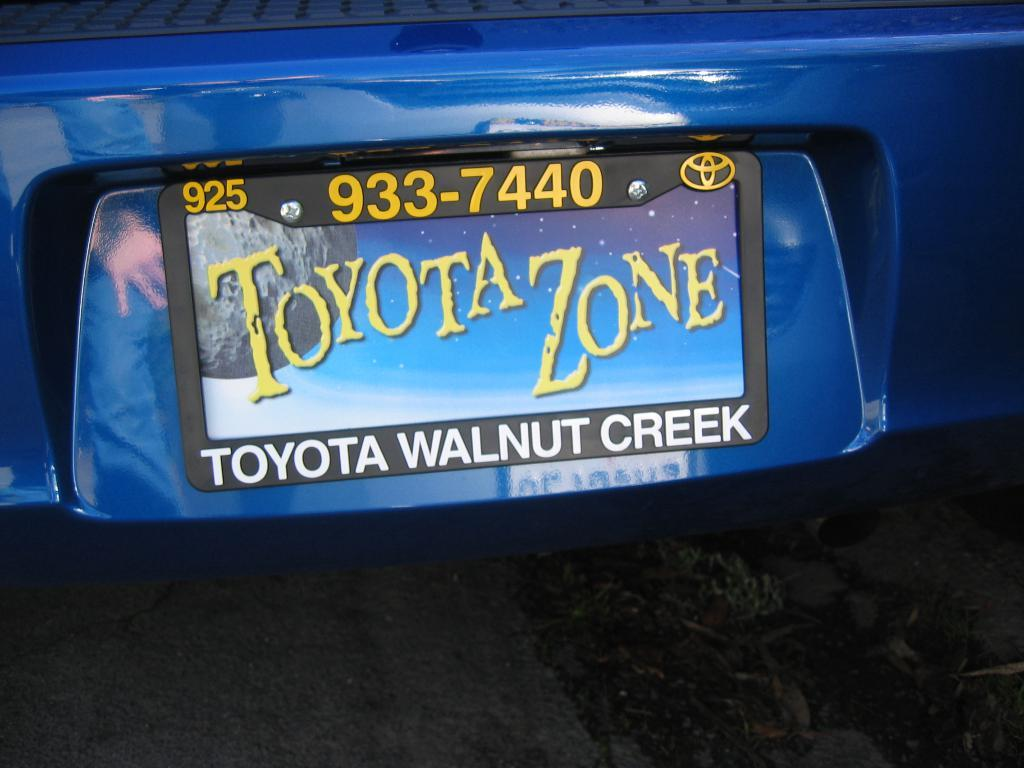<image>
Offer a succinct explanation of the picture presented. the words toyota zone on the license plate 